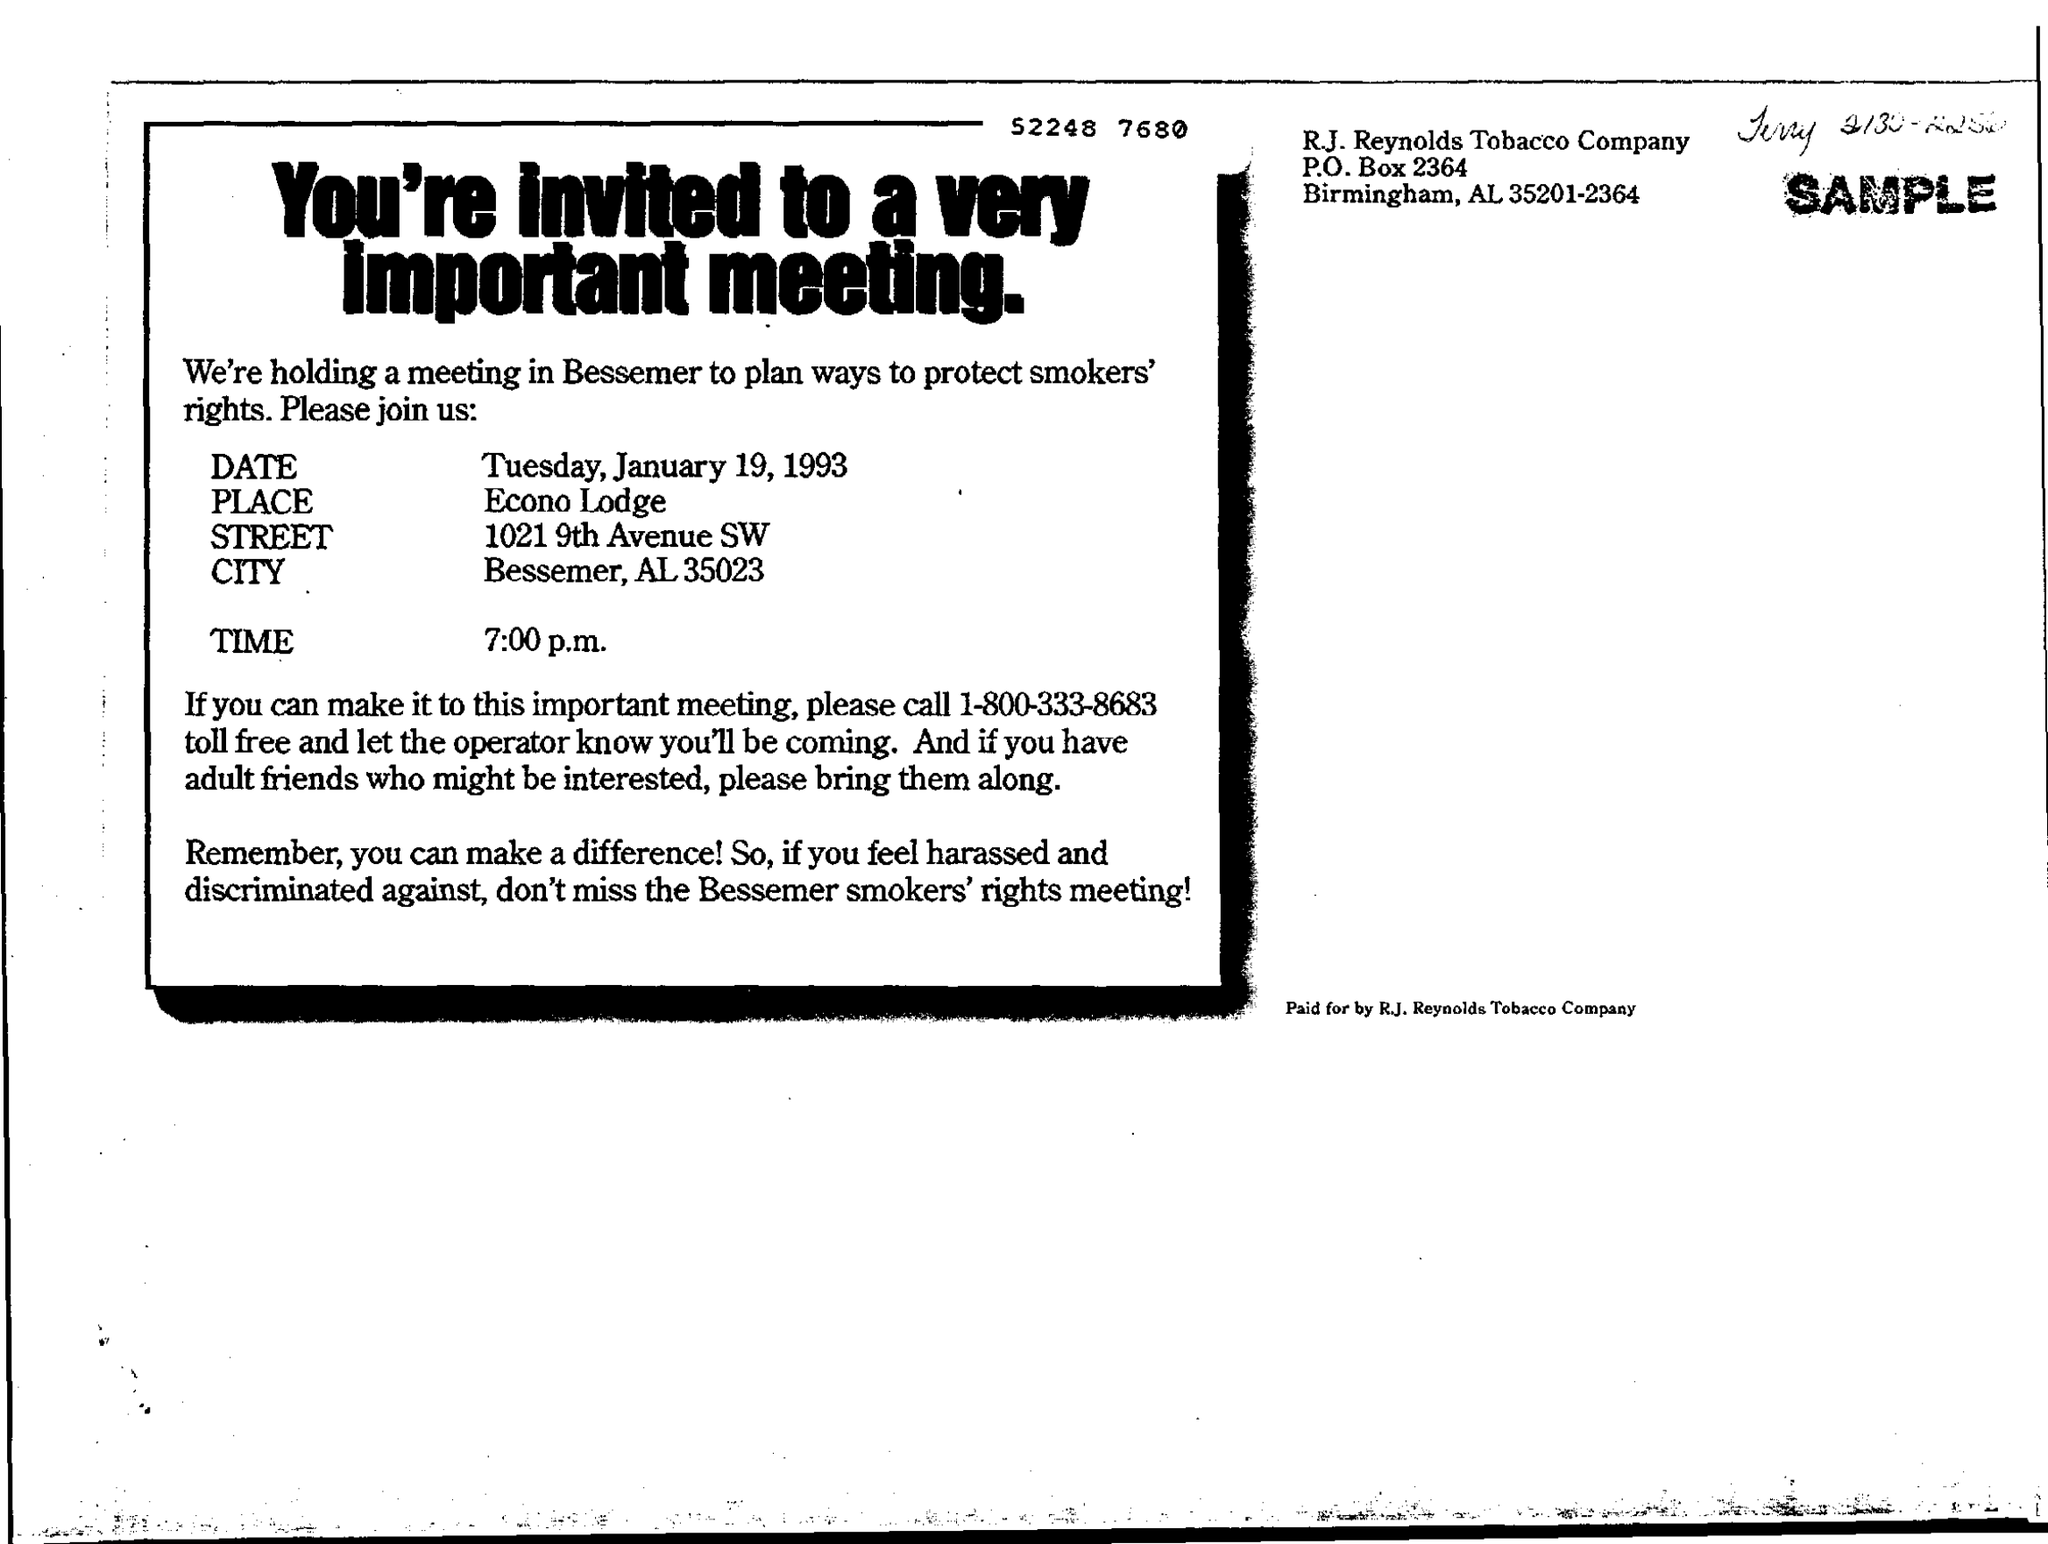On which date, the meeting is held?
Your answer should be very brief. Tuesday, January 19, 1993. Why this meeting is held in Bessemer?
Give a very brief answer. To plan ways to protect smokers' rights. In which city, the meeting is held?
Your answer should be very brief. Bessemer, AL 35023. On what time, the meeting is held?
Provide a succinct answer. 7:00 p.m. Which Company's invite is this?
Offer a very short reply. R.J. Reynolds Tobacco Company. 